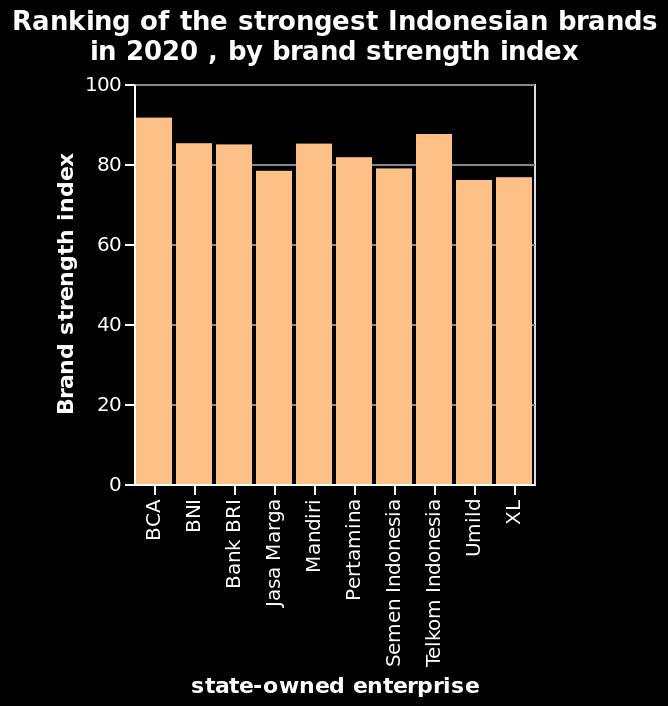<image>
What is measured on the y-axis of the bar diagram? The y-axis measures Brand strength index on a linear scale of range 0 to 100. Offer a thorough analysis of the image. All the brand strengths are over 70. 6 of the 10 companies have brand strength over 80. BCA has the highest brand strength and Umild has the lowest brand strength. 